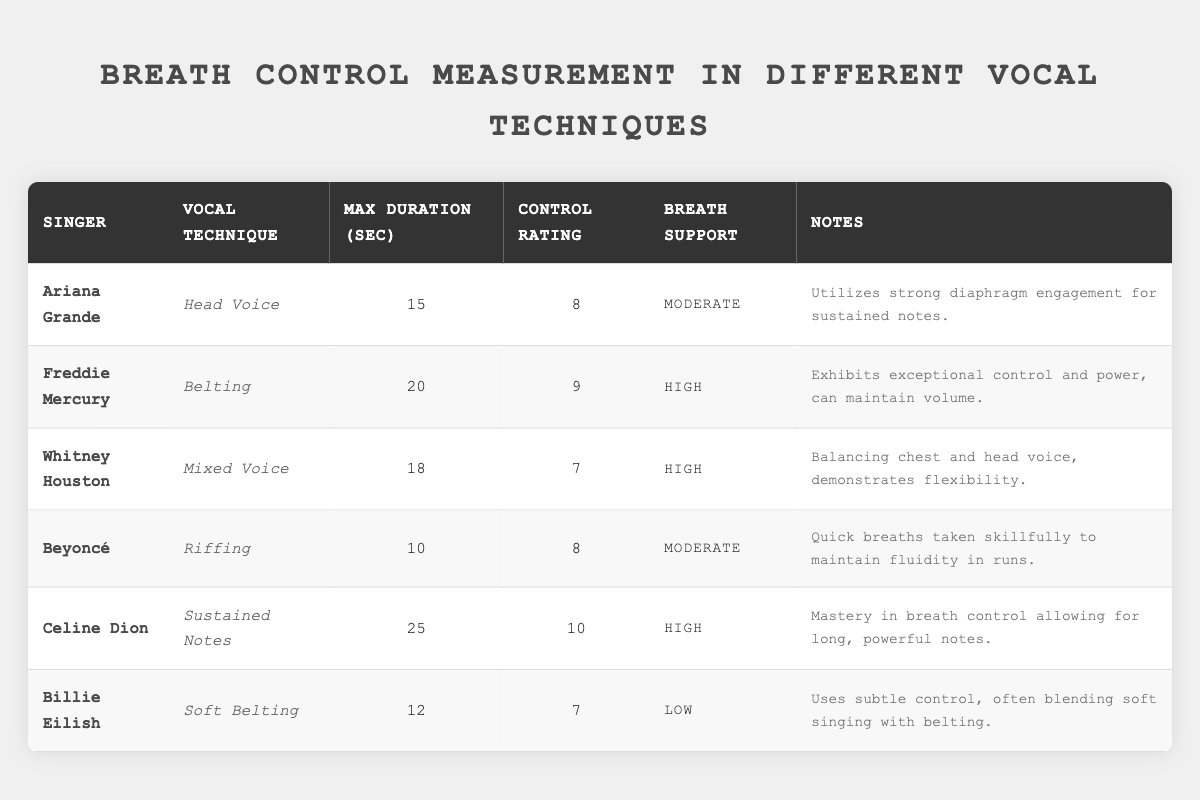What is the maximum duration achieved by Celine Dion in her vocal technique? The table shows that Celine Dion has a max duration of 25 seconds under her vocal technique of Sustained Notes.
Answer: 25 seconds Which singer has the highest control rating, and what is that rating? By examining the control ratings, Celine Dion has the highest control rating of 10.
Answer: Celine Dion, 10 What is the breath support level for Billie Eilish's technique? The table indicates that Billie Eilish has a breath support level of Low for her Soft Belting technique.
Answer: Low Who employs a mixed voice technique and what is the max duration for that technique? Whitney Houston utilizes a Mixed Voice technique with a maximum duration of 18 seconds.
Answer: Whitney Houston, 18 seconds Is it true that Ariana Grande has a higher max duration than Billie Eilish? Comparing the max durations, Ariana Grande at 15 seconds has a higher duration than Billie Eilish at 12 seconds, so the statement is true.
Answer: Yes Which two singers utilize high breath support and what are their control ratings? The two singers with high breath support are Freddie Mercury and Whitney Houston. Freddie Mercury has a control rating of 9, and Whitney Houston has a rating of 7.
Answer: Freddie Mercury 9, Whitney Houston 7 What is the average max duration of all singers listed in the table? To find the average max duration, sum the durations: (15 + 20 + 18 + 10 + 25 + 12) = 110. There are 6 singers, so the average is 110 / 6 = 18.33 seconds.
Answer: 18.33 seconds Which singer has the lowest control rating and what is that rating? Billie Eilish has the lowest control rating at 7, according to the table.
Answer: Billie Eilish, 7 How many singers have a control rating of 8 or higher? The singers with a control rating of 8 or higher are Ariana Grande, Freddie Mercury, Beyoncé, and Celine Dion, totaling 4 singers.
Answer: 4 singers What technique does Beyoncé use and what are the notes provided for her performance? Beyoncé uses Riffing as her vocal technique, and the notes state that she skillfully takes quick breaths to maintain fluidity in her runs.
Answer: Riffing, she skillfully takes quick breaths to maintain fluidity in runs 